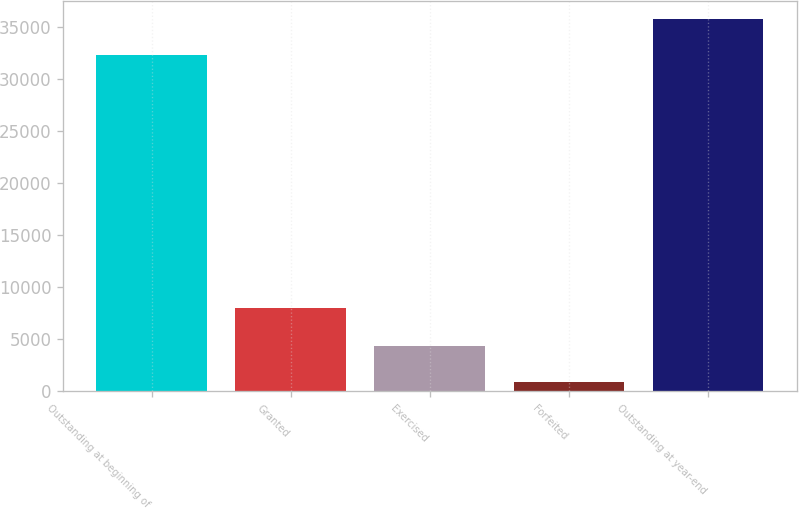Convert chart. <chart><loc_0><loc_0><loc_500><loc_500><bar_chart><fcel>Outstanding at beginning of<fcel>Granted<fcel>Exercised<fcel>Forfeited<fcel>Outstanding at year-end<nl><fcel>32301<fcel>7981<fcel>4387.9<fcel>931<fcel>35757.9<nl></chart> 